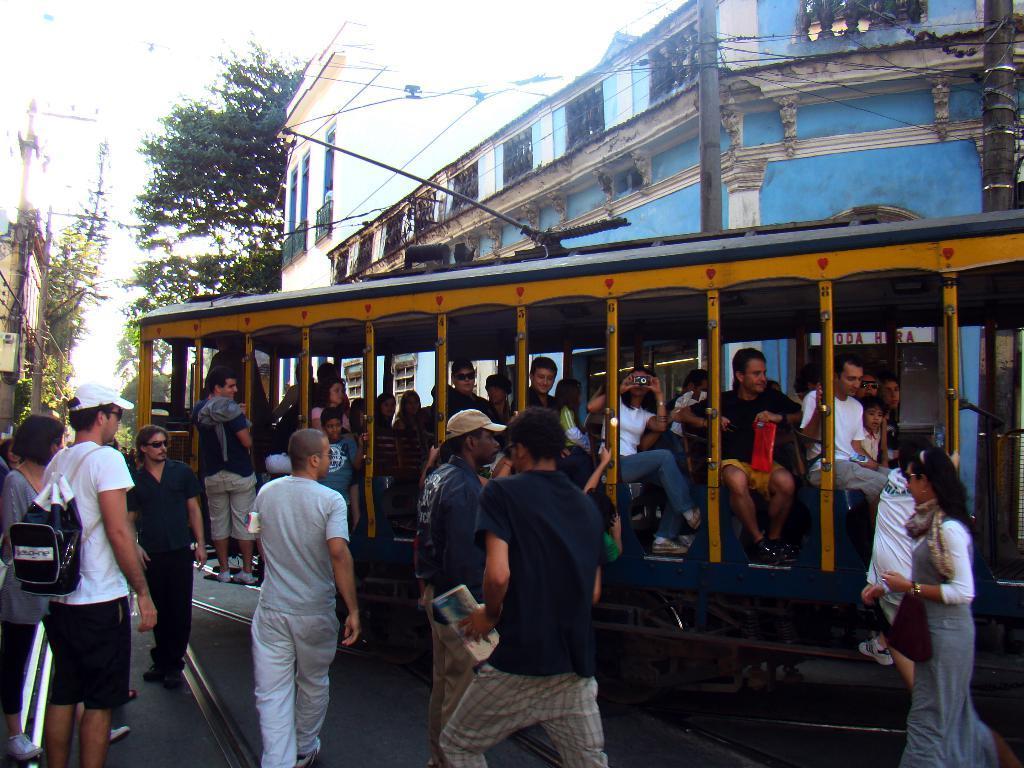How would you summarize this image in a sentence or two? In this image, there is an outside view. There are some persons in the middle of the image wearing clothes and sitting inside the vehicle which is beside the building. There are some other persons standing and wearing clothes. There is a tree in the top left of the image. 